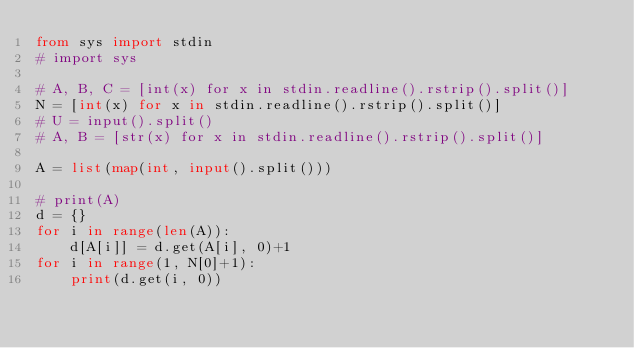<code> <loc_0><loc_0><loc_500><loc_500><_Python_>from sys import stdin
# import sys

# A, B, C = [int(x) for x in stdin.readline().rstrip().split()]
N = [int(x) for x in stdin.readline().rstrip().split()]
# U = input().split()
# A, B = [str(x) for x in stdin.readline().rstrip().split()]

A = list(map(int, input().split()))

# print(A)
d = {}
for i in range(len(A)):
    d[A[i]] = d.get(A[i], 0)+1
for i in range(1, N[0]+1):
    print(d.get(i, 0))
</code> 